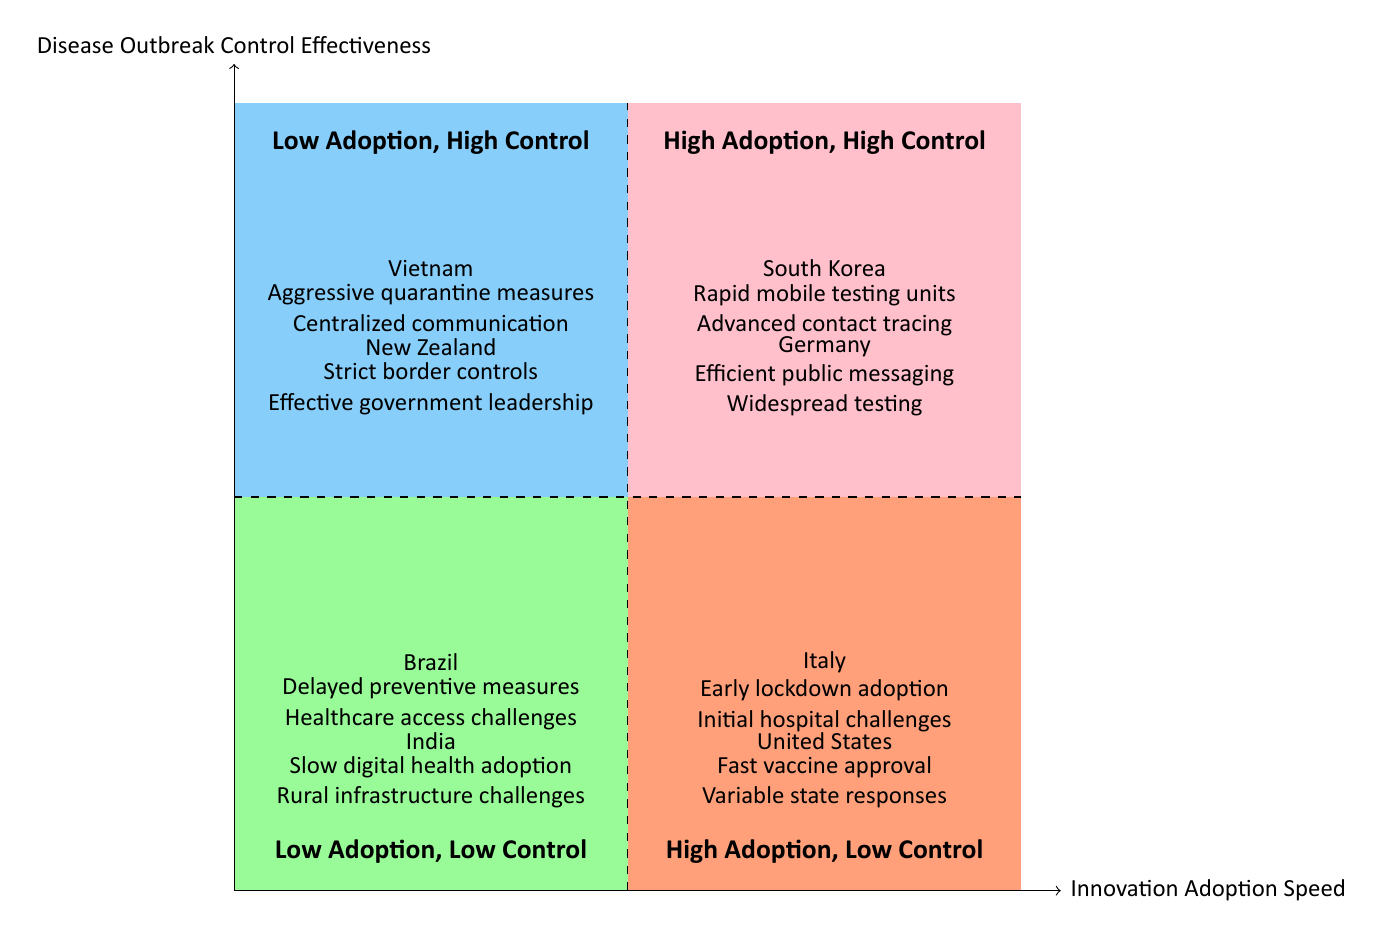What regions are in the "Low Adoption, High Control" quadrant? The "Low Adoption, High Control" quadrant contains two regions: Vietnam and New Zealand, where both implemented robust outbreak control measures despite a lower pace of innovation adoption.
Answer: Vietnam, New Zealand How many regions are in the "High Adoption, High Control" quadrant? There are two regions in the "High Adoption, High Control" quadrant: South Korea and Germany.
Answer: 2 What key initiative is shared by both South Korea and Germany? Both South Korea and Germany focus on public health messaging and widespread testing as essential components of their strategies to control disease outbreaks.
Answer: Public health messaging Which two regions have "High Adoption, Low Control"? The two regions in the "High Adoption, Low Control" quadrant are Italy and the United States, indicating they adopted innovations rapidly but faced challenges in controlling disease outbreaks effectively.
Answer: Italy, United States Which region has the most significant initiatives in the "Low Adoption, Low Control" quadrant? Both Brazil and India have challenges, but Brazil's notable initiatives include delayed responses and limited healthcare access, while India's issues are primarily with slow digital adoption and rural infrastructure. The focus on delayed responses makes Brazil stand out here.
Answer: Brazil What commonality exists between Vietnam and New Zealand's approaches? Both regions emphasize strict control measures and centralized governance for effective disease management, demonstrating their commitment to controlling outbreaks despite slower innovation adoption.
Answer: Strict control measures Which quadrant features regions with mixed effectiveness and innovation adoption speeds? The "High Adoption, Low Control" quadrant features regions with this mixed situation, where rapid innovation adoption did not guarantee effective outbreak control.
Answer: High Adoption, Low Control What type of public health strategy is indicated for the United States within the "High Adoption, Low Control" quadrant? The United States showcases a high variability in state-level responses, suggesting an inconsistent approach to public health strategy amidst rapid innovation in vaccine development.
Answer: High variability in state-level responses 